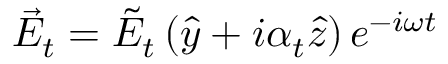<formula> <loc_0><loc_0><loc_500><loc_500>\vec { E } _ { t } = \tilde { E } _ { t } \left ( \hat { y } + i \alpha _ { t } \hat { z } \right ) e ^ { - i \omega t }</formula> 